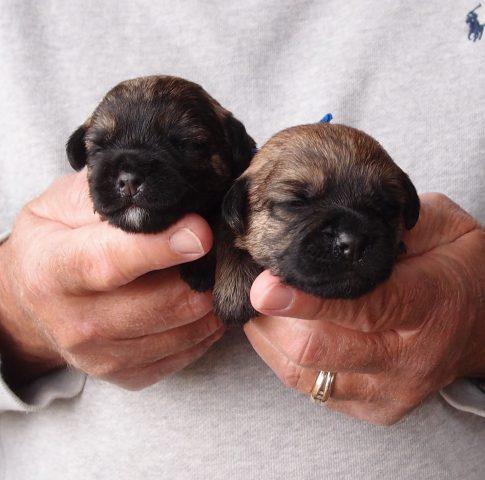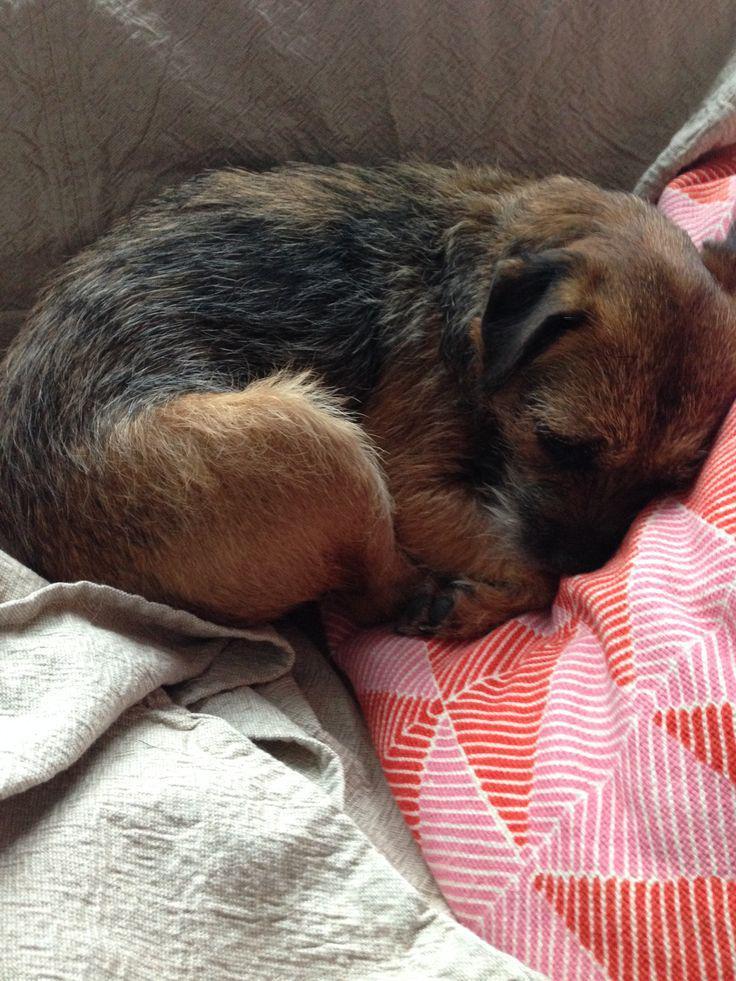The first image is the image on the left, the second image is the image on the right. For the images displayed, is the sentence "One image shows two dogs with their heads close together." factually correct? Answer yes or no. Yes. The first image is the image on the left, the second image is the image on the right. Analyze the images presented: Is the assertion "There is only one dog in each picture." valid? Answer yes or no. No. 